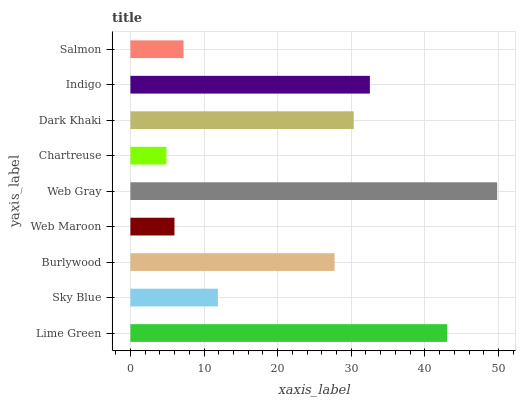Is Chartreuse the minimum?
Answer yes or no. Yes. Is Web Gray the maximum?
Answer yes or no. Yes. Is Sky Blue the minimum?
Answer yes or no. No. Is Sky Blue the maximum?
Answer yes or no. No. Is Lime Green greater than Sky Blue?
Answer yes or no. Yes. Is Sky Blue less than Lime Green?
Answer yes or no. Yes. Is Sky Blue greater than Lime Green?
Answer yes or no. No. Is Lime Green less than Sky Blue?
Answer yes or no. No. Is Burlywood the high median?
Answer yes or no. Yes. Is Burlywood the low median?
Answer yes or no. Yes. Is Dark Khaki the high median?
Answer yes or no. No. Is Chartreuse the low median?
Answer yes or no. No. 